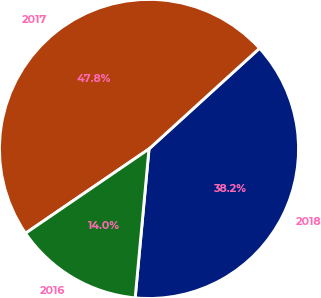Convert chart. <chart><loc_0><loc_0><loc_500><loc_500><pie_chart><fcel>2018<fcel>2017<fcel>2016<nl><fcel>38.23%<fcel>47.78%<fcel>13.99%<nl></chart> 